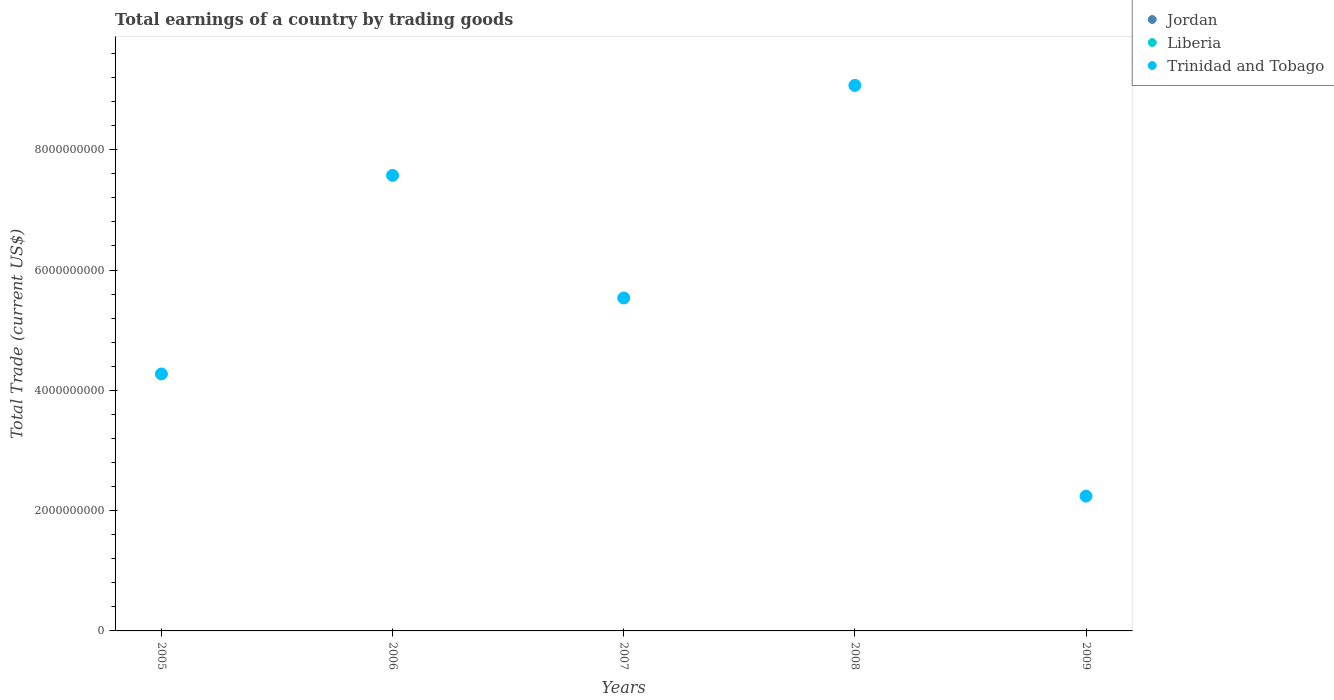How many different coloured dotlines are there?
Give a very brief answer. 1. What is the total earnings in Trinidad and Tobago in 2007?
Provide a succinct answer. 5.54e+09. Across all years, what is the maximum total earnings in Trinidad and Tobago?
Offer a terse response. 9.07e+09. In which year was the total earnings in Trinidad and Tobago maximum?
Keep it short and to the point. 2008. What is the difference between the total earnings in Trinidad and Tobago in 2005 and that in 2006?
Offer a terse response. -3.30e+09. What is the difference between the total earnings in Trinidad and Tobago in 2006 and the total earnings in Liberia in 2007?
Your response must be concise. 7.57e+09. What is the average total earnings in Trinidad and Tobago per year?
Provide a short and direct response. 5.74e+09. In how many years, is the total earnings in Liberia greater than 3600000000 US$?
Your response must be concise. 0. What is the ratio of the total earnings in Trinidad and Tobago in 2007 to that in 2009?
Provide a succinct answer. 2.47. Is the total earnings in Trinidad and Tobago in 2005 less than that in 2006?
Your response must be concise. Yes. What is the difference between the highest and the second highest total earnings in Trinidad and Tobago?
Your answer should be very brief. 1.50e+09. Is the sum of the total earnings in Trinidad and Tobago in 2006 and 2007 greater than the maximum total earnings in Liberia across all years?
Provide a succinct answer. Yes. Is it the case that in every year, the sum of the total earnings in Liberia and total earnings in Trinidad and Tobago  is greater than the total earnings in Jordan?
Offer a very short reply. Yes. Does the total earnings in Trinidad and Tobago monotonically increase over the years?
Make the answer very short. No. How many dotlines are there?
Your response must be concise. 1. How many legend labels are there?
Your answer should be compact. 3. What is the title of the graph?
Your answer should be very brief. Total earnings of a country by trading goods. Does "Haiti" appear as one of the legend labels in the graph?
Make the answer very short. No. What is the label or title of the Y-axis?
Ensure brevity in your answer.  Total Trade (current US$). What is the Total Trade (current US$) in Trinidad and Tobago in 2005?
Offer a very short reply. 4.27e+09. What is the Total Trade (current US$) in Jordan in 2006?
Your answer should be compact. 0. What is the Total Trade (current US$) of Trinidad and Tobago in 2006?
Your answer should be very brief. 7.57e+09. What is the Total Trade (current US$) of Jordan in 2007?
Offer a terse response. 0. What is the Total Trade (current US$) in Liberia in 2007?
Offer a very short reply. 0. What is the Total Trade (current US$) of Trinidad and Tobago in 2007?
Ensure brevity in your answer.  5.54e+09. What is the Total Trade (current US$) in Jordan in 2008?
Ensure brevity in your answer.  0. What is the Total Trade (current US$) of Trinidad and Tobago in 2008?
Offer a terse response. 9.07e+09. What is the Total Trade (current US$) in Trinidad and Tobago in 2009?
Offer a very short reply. 2.24e+09. Across all years, what is the maximum Total Trade (current US$) in Trinidad and Tobago?
Offer a very short reply. 9.07e+09. Across all years, what is the minimum Total Trade (current US$) in Trinidad and Tobago?
Ensure brevity in your answer.  2.24e+09. What is the total Total Trade (current US$) of Trinidad and Tobago in the graph?
Provide a succinct answer. 2.87e+1. What is the difference between the Total Trade (current US$) in Trinidad and Tobago in 2005 and that in 2006?
Your answer should be very brief. -3.30e+09. What is the difference between the Total Trade (current US$) of Trinidad and Tobago in 2005 and that in 2007?
Give a very brief answer. -1.26e+09. What is the difference between the Total Trade (current US$) of Trinidad and Tobago in 2005 and that in 2008?
Your response must be concise. -4.80e+09. What is the difference between the Total Trade (current US$) of Trinidad and Tobago in 2005 and that in 2009?
Provide a short and direct response. 2.03e+09. What is the difference between the Total Trade (current US$) of Trinidad and Tobago in 2006 and that in 2007?
Your answer should be very brief. 2.04e+09. What is the difference between the Total Trade (current US$) of Trinidad and Tobago in 2006 and that in 2008?
Make the answer very short. -1.50e+09. What is the difference between the Total Trade (current US$) in Trinidad and Tobago in 2006 and that in 2009?
Offer a very short reply. 5.33e+09. What is the difference between the Total Trade (current US$) of Trinidad and Tobago in 2007 and that in 2008?
Keep it short and to the point. -3.53e+09. What is the difference between the Total Trade (current US$) of Trinidad and Tobago in 2007 and that in 2009?
Offer a very short reply. 3.29e+09. What is the difference between the Total Trade (current US$) of Trinidad and Tobago in 2008 and that in 2009?
Provide a succinct answer. 6.83e+09. What is the average Total Trade (current US$) of Trinidad and Tobago per year?
Provide a short and direct response. 5.74e+09. What is the ratio of the Total Trade (current US$) of Trinidad and Tobago in 2005 to that in 2006?
Keep it short and to the point. 0.56. What is the ratio of the Total Trade (current US$) of Trinidad and Tobago in 2005 to that in 2007?
Make the answer very short. 0.77. What is the ratio of the Total Trade (current US$) of Trinidad and Tobago in 2005 to that in 2008?
Your response must be concise. 0.47. What is the ratio of the Total Trade (current US$) of Trinidad and Tobago in 2005 to that in 2009?
Ensure brevity in your answer.  1.91. What is the ratio of the Total Trade (current US$) in Trinidad and Tobago in 2006 to that in 2007?
Provide a short and direct response. 1.37. What is the ratio of the Total Trade (current US$) of Trinidad and Tobago in 2006 to that in 2008?
Provide a short and direct response. 0.84. What is the ratio of the Total Trade (current US$) of Trinidad and Tobago in 2006 to that in 2009?
Make the answer very short. 3.38. What is the ratio of the Total Trade (current US$) of Trinidad and Tobago in 2007 to that in 2008?
Keep it short and to the point. 0.61. What is the ratio of the Total Trade (current US$) of Trinidad and Tobago in 2007 to that in 2009?
Offer a very short reply. 2.47. What is the ratio of the Total Trade (current US$) of Trinidad and Tobago in 2008 to that in 2009?
Offer a very short reply. 4.05. What is the difference between the highest and the second highest Total Trade (current US$) in Trinidad and Tobago?
Keep it short and to the point. 1.50e+09. What is the difference between the highest and the lowest Total Trade (current US$) in Trinidad and Tobago?
Provide a succinct answer. 6.83e+09. 